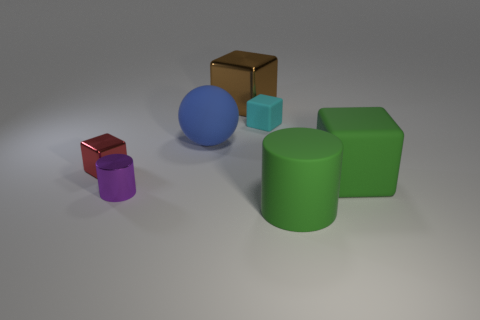There is a big rubber thing that is the same color as the matte cylinder; what shape is it?
Your answer should be very brief. Cube. Is the number of rubber blocks behind the red metallic thing greater than the number of small blue metallic spheres?
Your response must be concise. Yes. What is the size of the brown cube that is the same material as the purple cylinder?
Make the answer very short. Large. Are there any green matte objects behind the cyan matte object?
Offer a terse response. No. Is the big metallic object the same shape as the tiny matte thing?
Offer a terse response. Yes. What is the size of the metal object left of the purple metallic cylinder right of the small shiny thing that is behind the tiny purple object?
Ensure brevity in your answer.  Small. What is the green block made of?
Give a very brief answer. Rubber. What size is the matte thing that is the same color as the big matte block?
Provide a short and direct response. Large. There is a small rubber thing; is its shape the same as the large green thing behind the big green matte cylinder?
Make the answer very short. Yes. What material is the cylinder left of the green object to the left of the large block in front of the brown metal thing made of?
Keep it short and to the point. Metal. 